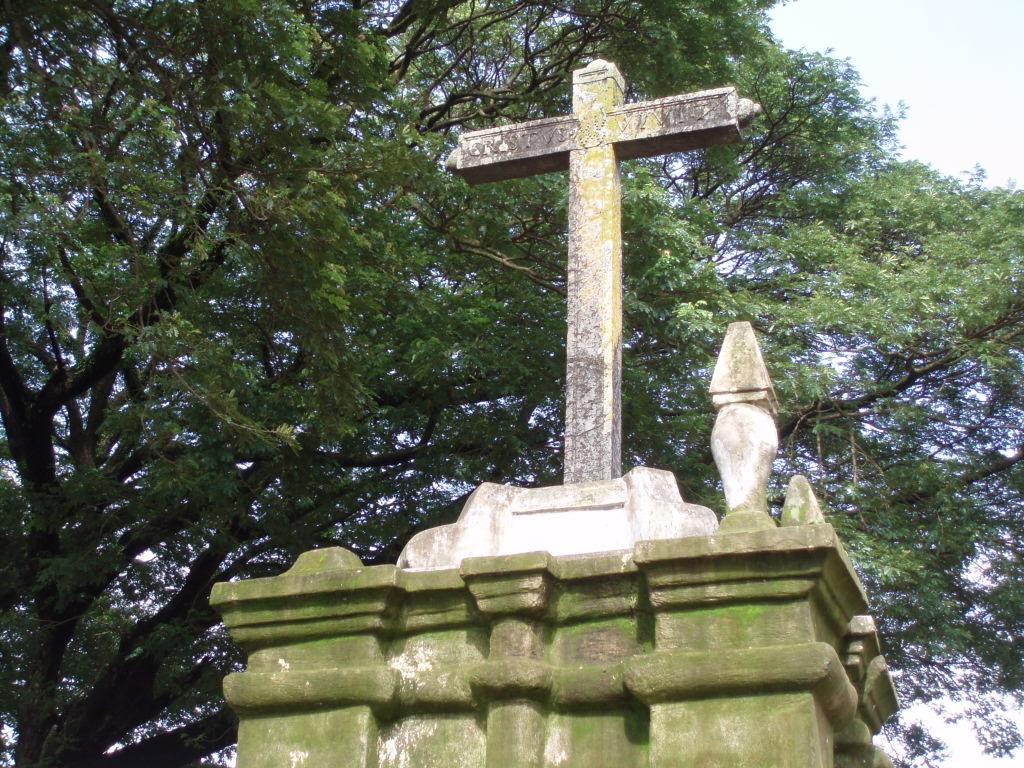What is the main object in the image? There is a big pillow with a cross symbol in the image. What can be seen near the pillow? There are trees beside the pillow in the image. What type of songs can be heard coming from the pillow in the image? There are no songs or sounds associated with the pillow in the image. 